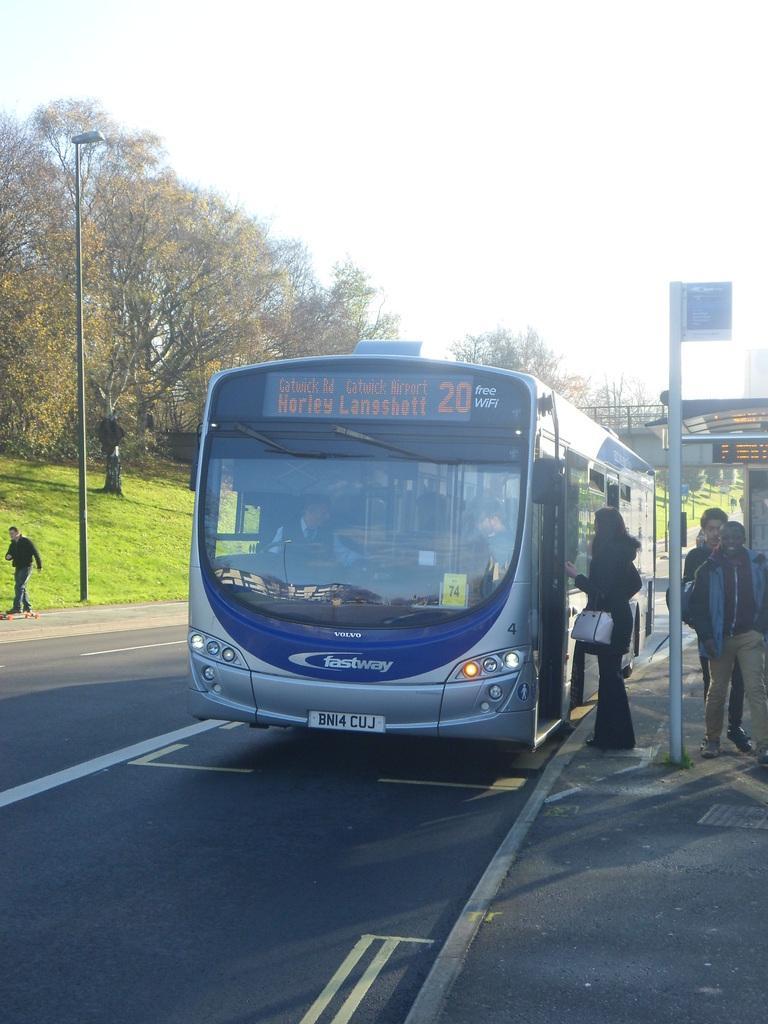Describe this image in one or two sentences. In the foreground of this image, there is a bus on the road. On the right, there is a pole and few persons standing on the side path. In the background, there is a shelter, trees, a light pole, a man on the skateboards, grass and the sky. 